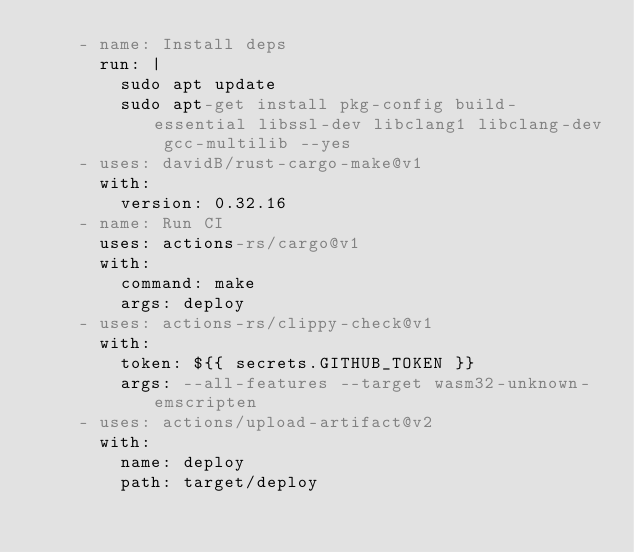<code> <loc_0><loc_0><loc_500><loc_500><_YAML_>    - name: Install deps
      run: |
        sudo apt update
        sudo apt-get install pkg-config build-essential libssl-dev libclang1 libclang-dev gcc-multilib --yes
    - uses: davidB/rust-cargo-make@v1
      with:
        version: 0.32.16
    - name: Run CI
      uses: actions-rs/cargo@v1
      with:
        command: make
        args: deploy
    - uses: actions-rs/clippy-check@v1
      with:
        token: ${{ secrets.GITHUB_TOKEN }}
        args: --all-features --target wasm32-unknown-emscripten
    - uses: actions/upload-artifact@v2
      with:
        name: deploy
        path: target/deploy
</code> 